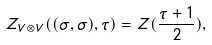Convert formula to latex. <formula><loc_0><loc_0><loc_500><loc_500>Z _ { V \otimes V } ( ( \sigma , \sigma ) , \tau ) = Z ( \frac { \tau + 1 } { 2 } ) ,</formula> 